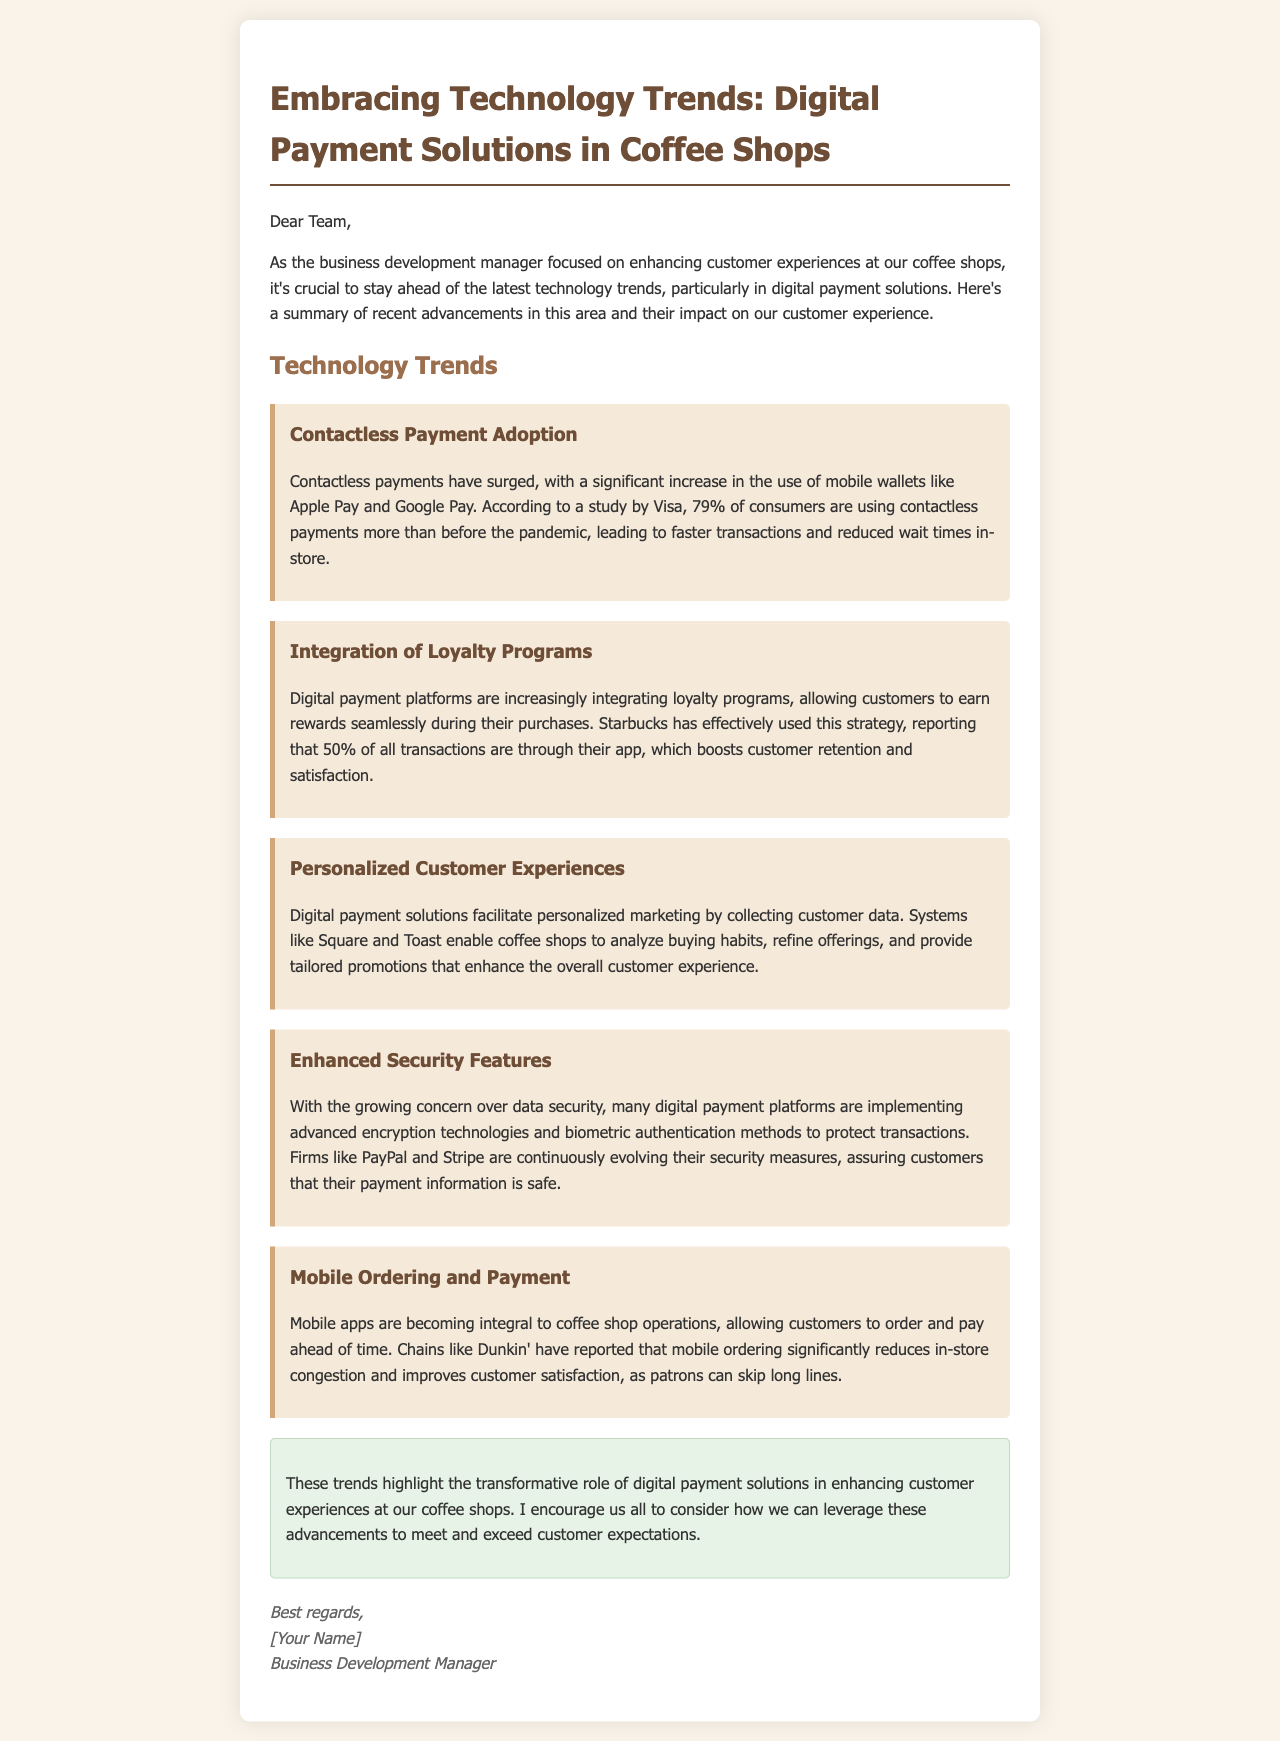what percentage of consumers are using contactless payments more than before the pandemic? The document states that according to a study by Visa, 79% of consumers are using contactless payments more than before the pandemic.
Answer: 79% which digital payment platform allows customers to earn rewards seamlessly during their purchases? The document mentions that digital payment platforms are increasingly integrating loyalty programs, specifically referencing that Starbucks effectively uses this strategy.
Answer: Starbucks what is the reported percentage of transactions through the Starbucks app? The document specifies that Starbucks has reported that 50% of all transactions are through their app.
Answer: 50% what is one major benefit of mobile ordering according to Dunkin'? The document states that Dunkin' has reported that mobile ordering significantly reduces in-store congestion.
Answer: reduces congestion which company is mentioned as implementing advanced encryption technologies for security? The document highlights that firms like PayPal and Stripe are continuously evolving their security measures.
Answer: PayPal what is a key feature of digital payment solutions in enhancing customer experience? The document mentions that digital payment solutions facilitate personalized marketing by collecting customer data.
Answer: personalized marketing how do digital payment solutions help with customer data? The document indicates that systems like Square and Toast enable coffee shops to analyze buying habits.
Answer: analyze buying habits who is the sender of the email? The signature at the end of the document indicates the sender is the Business Development Manager.
Answer: Business Development Manager 